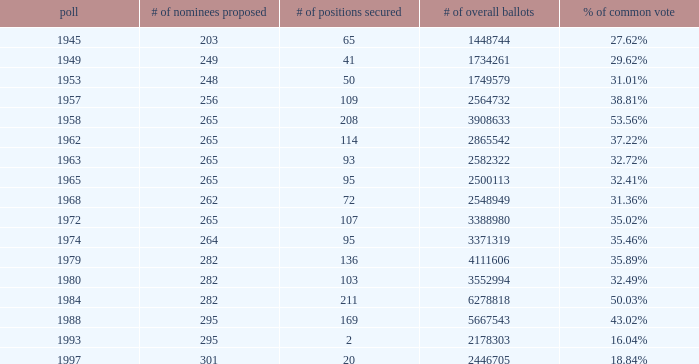What is the election year when the # of candidates nominated was 262? 1.0. 